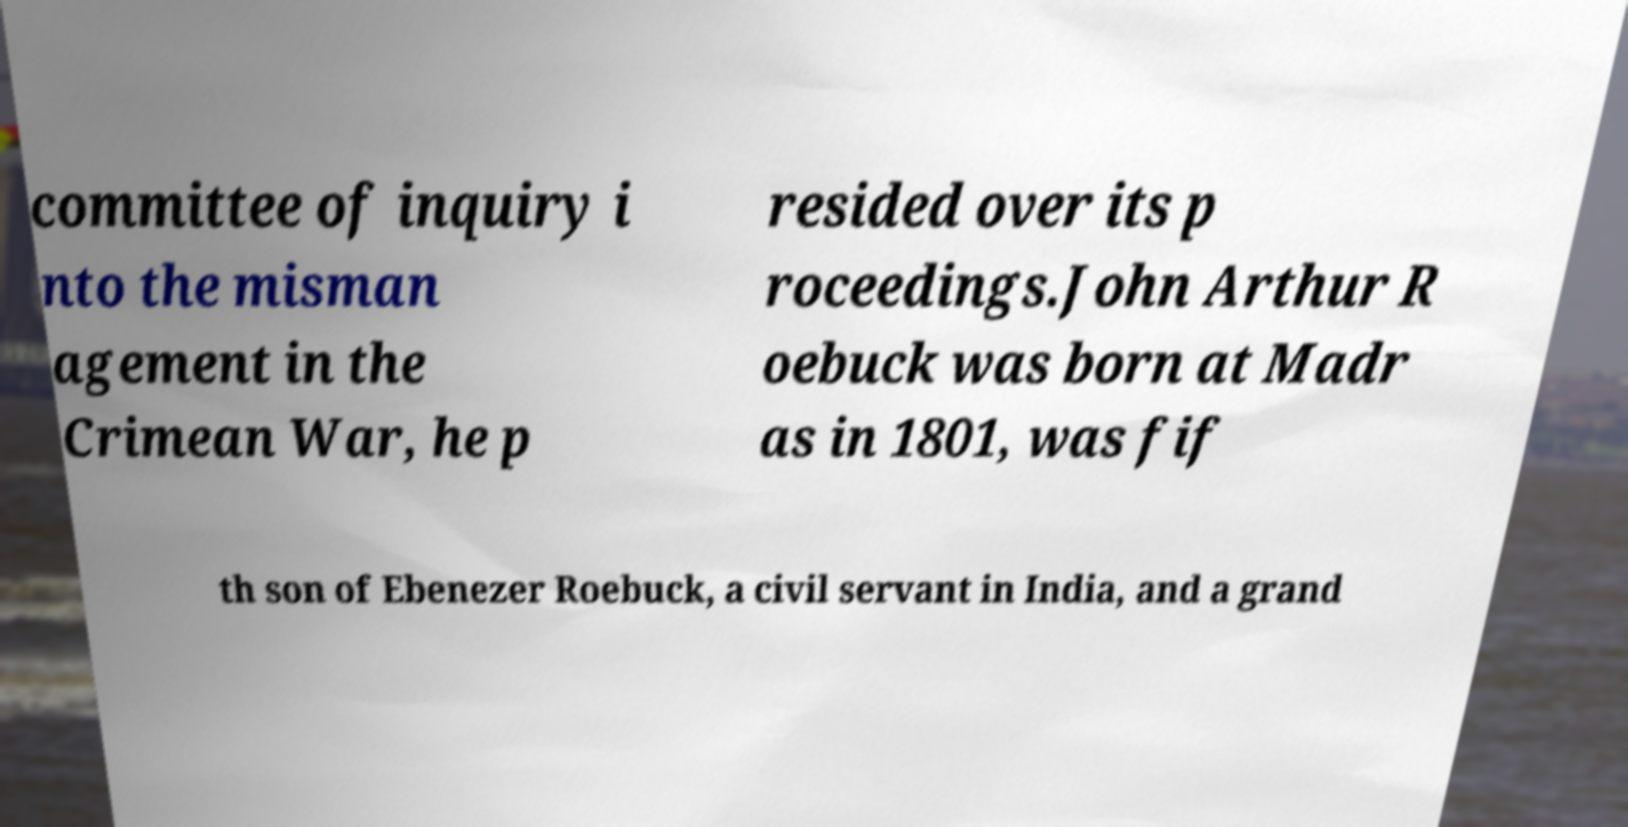Can you read and provide the text displayed in the image?This photo seems to have some interesting text. Can you extract and type it out for me? committee of inquiry i nto the misman agement in the Crimean War, he p resided over its p roceedings.John Arthur R oebuck was born at Madr as in 1801, was fif th son of Ebenezer Roebuck, a civil servant in India, and a grand 